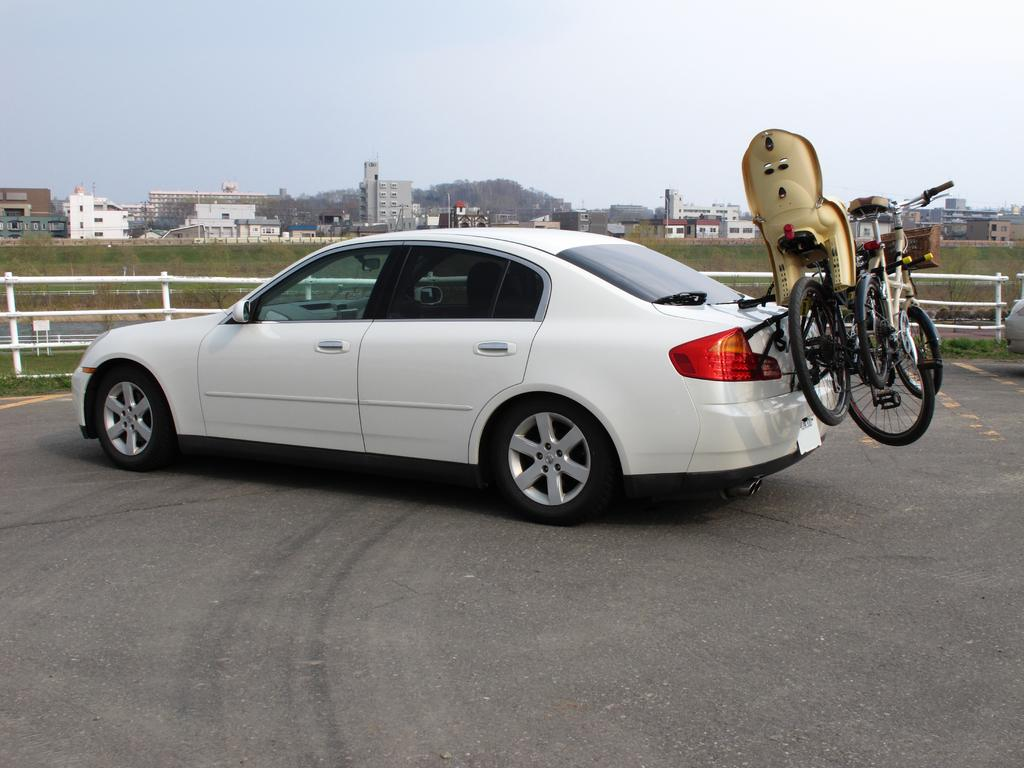What is attached to the backside of the car in the image? There are bicycles attached to the backside of the car in the image. What can be seen in the distance behind the car? There are buildings and trees visible in the background of the image. What type of dock can be seen in the image? There is no dock present in the image. 